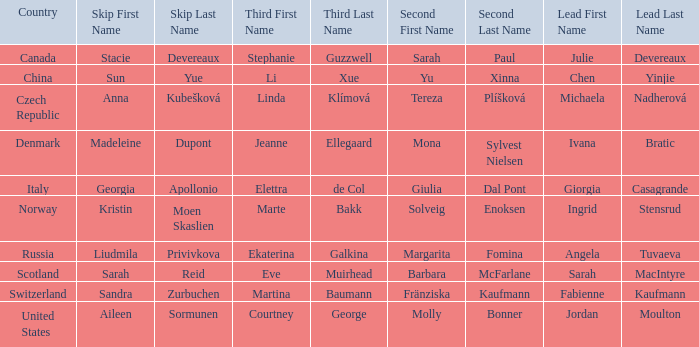What skip has switzerland as the country? Sandra Zurbuchen. 